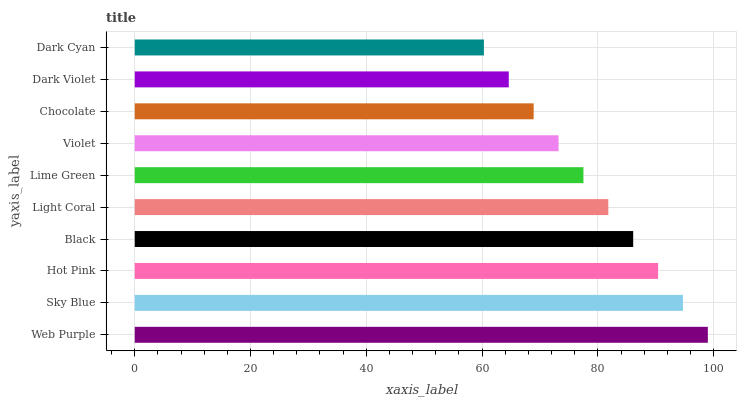Is Dark Cyan the minimum?
Answer yes or no. Yes. Is Web Purple the maximum?
Answer yes or no. Yes. Is Sky Blue the minimum?
Answer yes or no. No. Is Sky Blue the maximum?
Answer yes or no. No. Is Web Purple greater than Sky Blue?
Answer yes or no. Yes. Is Sky Blue less than Web Purple?
Answer yes or no. Yes. Is Sky Blue greater than Web Purple?
Answer yes or no. No. Is Web Purple less than Sky Blue?
Answer yes or no. No. Is Light Coral the high median?
Answer yes or no. Yes. Is Lime Green the low median?
Answer yes or no. Yes. Is Hot Pink the high median?
Answer yes or no. No. Is Black the low median?
Answer yes or no. No. 